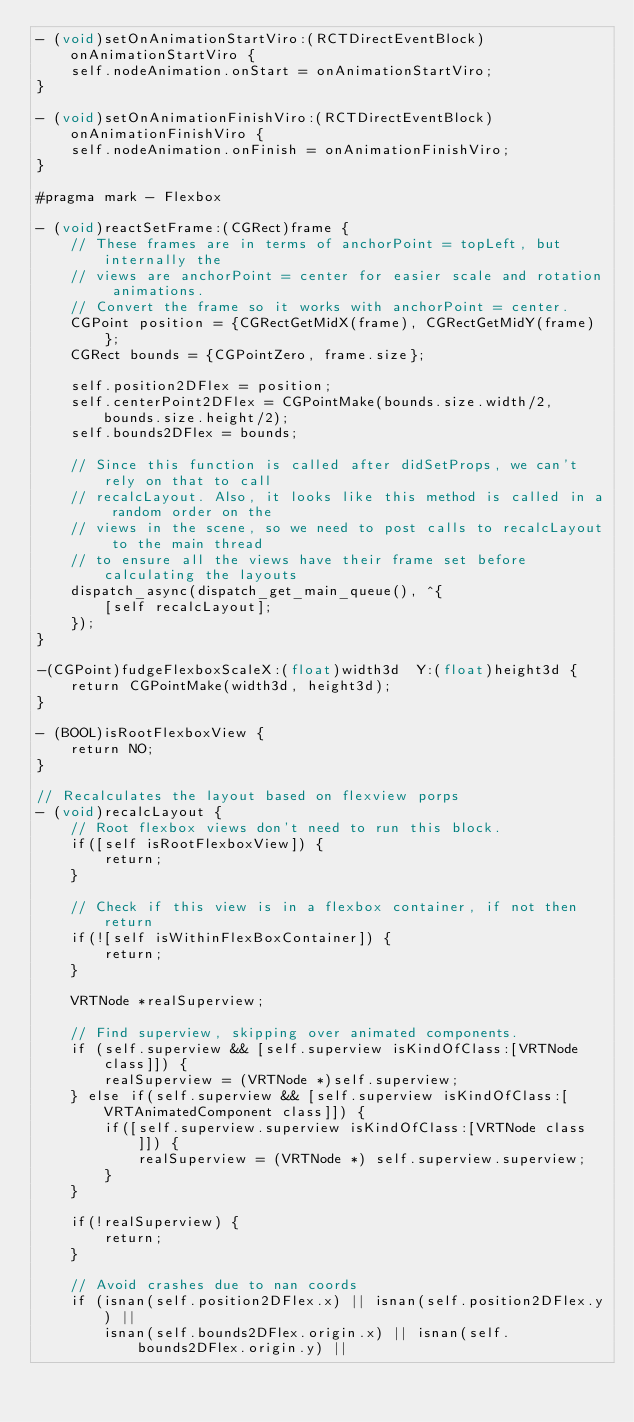<code> <loc_0><loc_0><loc_500><loc_500><_ObjectiveC_>- (void)setOnAnimationStartViro:(RCTDirectEventBlock)onAnimationStartViro {
    self.nodeAnimation.onStart = onAnimationStartViro;
}

- (void)setOnAnimationFinishViro:(RCTDirectEventBlock)onAnimationFinishViro {
    self.nodeAnimation.onFinish = onAnimationFinishViro;
}

#pragma mark - Flexbox

- (void)reactSetFrame:(CGRect)frame {
    // These frames are in terms of anchorPoint = topLeft, but internally the
    // views are anchorPoint = center for easier scale and rotation animations.
    // Convert the frame so it works with anchorPoint = center.
    CGPoint position = {CGRectGetMidX(frame), CGRectGetMidY(frame)};
    CGRect bounds = {CGPointZero, frame.size};
    
    self.position2DFlex = position;
    self.centerPoint2DFlex = CGPointMake(bounds.size.width/2, bounds.size.height/2);
    self.bounds2DFlex = bounds;

    // Since this function is called after didSetProps, we can't rely on that to call
    // recalcLayout. Also, it looks like this method is called in a random order on the
    // views in the scene, so we need to post calls to recalcLayout to the main thread
    // to ensure all the views have their frame set before calculating the layouts
    dispatch_async(dispatch_get_main_queue(), ^{
        [self recalcLayout];
    });
}

-(CGPoint)fudgeFlexboxScaleX:(float)width3d  Y:(float)height3d {
    return CGPointMake(width3d, height3d);
}

- (BOOL)isRootFlexboxView {
    return NO;
}

// Recalculates the layout based on flexview porps
- (void)recalcLayout {
    // Root flexbox views don't need to run this block.
    if([self isRootFlexboxView]) {
        return;
    }
    
    // Check if this view is in a flexbox container, if not then return
    if(![self isWithinFlexBoxContainer]) {
        return;
    }

    VRTNode *realSuperview;
    
    // Find superview, skipping over animated components.
    if (self.superview && [self.superview isKindOfClass:[VRTNode class]]) {
        realSuperview = (VRTNode *)self.superview;
    } else if(self.superview && [self.superview isKindOfClass:[VRTAnimatedComponent class]]) {
        if([self.superview.superview isKindOfClass:[VRTNode class]]) {
            realSuperview = (VRTNode *) self.superview.superview;
        }
    }
    
    if(!realSuperview) {
        return;
    }
    
    // Avoid crashes due to nan coords
    if (isnan(self.position2DFlex.x) || isnan(self.position2DFlex.y) ||
        isnan(self.bounds2DFlex.origin.x) || isnan(self.bounds2DFlex.origin.y) ||</code> 